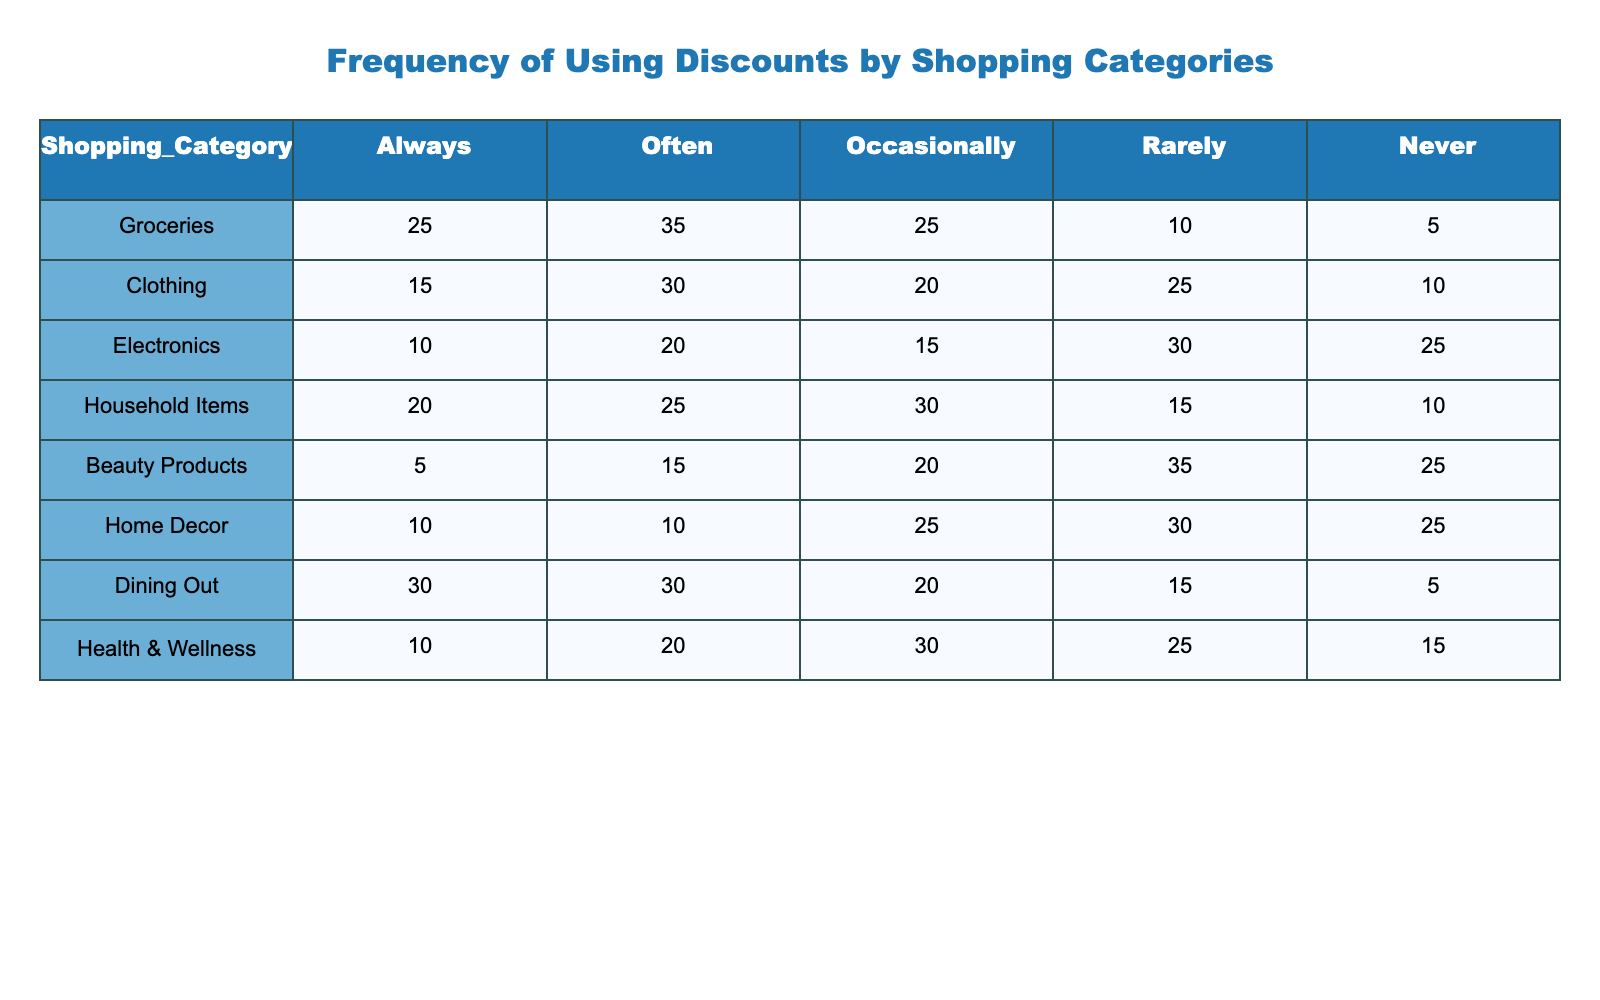What percentage of people always use discounts for groceries? In the table, 25 people always use discounts for groceries. To find the percentage, we consider that the total frequency count for groceries is 25 + 35 + 25 + 10 + 5 = 100. Thus, the percentage is (25/100) * 100 = 25%.
Answer: 25% What is the frequency of people that never use discounts for clothing? The table shows that 10 people never use discounts when shopping for clothing. This is directly represented in the 'Never' row for the Clothing category.
Answer: 10 Which shopping category has the highest percentage of people who always use discounts? By comparing the 'Always' column, Groceries has 25, Clothing has 15, Electronics has 10, Household Items has 20, Beauty Products has 5, Home Decor has 10, Dining Out has 30, and Health & Wellness has 10. The highest value is 30 for Dining Out.
Answer: Dining Out What is the sum of the frequencies of people who occasionally use discounts across all categories? By looking at the 'Occasionally' row, we find these frequencies: 25 (Groceries) + 20 (Clothing) + 15 (Electronics) + 30 (Household Items) + 20 (Beauty Products) + 25 (Home Decor) + 20 (Dining Out) + 30 (Health & Wellness). Summing these gives us 25 + 20 + 15 + 30 + 20 + 25 + 20 + 30 = 185.
Answer: 185 Is it true that more people rarely use discounts for Household Items than for Beauty Products? Looking at the 'Rarely' column, we find 15 people for Household Items and 35 for Beauty Products. Since 15 is less than 35, the statement is false.
Answer: No What is the average number of people who often use discounts for the categories containing 'Items' in their name? We identify two categories: Household Items (25) and Beauty Products (15). The sum is 25 + 15 = 40. There are 2 categories, so the average is 40/2 = 20.
Answer: 20 Which category has the most significant difference between the 'Never' and 'Always' discount usage? We calculate the difference for each category: Groceries (25 - 5 = 20), Clothing (15 - 10 = 5), Electronics (10 - 25 = -15), Household Items (20 - 10 = 10), Beauty Products (5 - 25 = -20), Home Decor (10 - 25 = -15), Dining Out (30 - 5 = 25), Health & Wellness (10 - 15 = -5). The highest difference is 25 for Dining Out.
Answer: Dining Out 